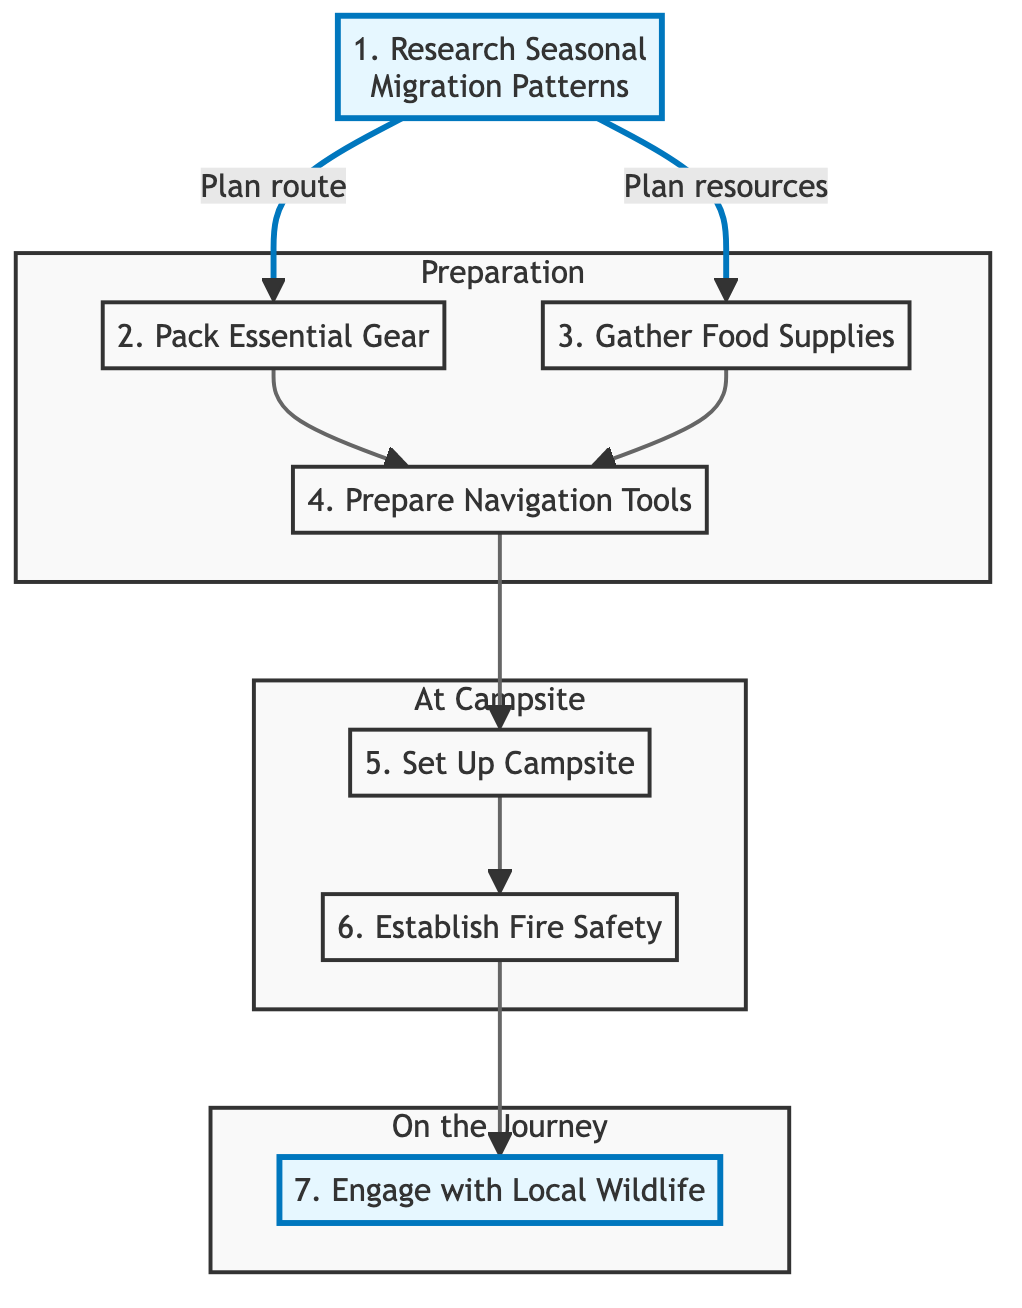What is the first step in the flow chart? The first step in the flow chart is the node labeled "Research Seasonal Migration Patterns." It is the starting point of the flow and serves as the foundation for the subsequent actions.
Answer: Research Seasonal Migration Patterns How many nodes are present in this diagram? The diagram contains a total of seven nodes, each representing a distinct step in preparing for a nomadic journey.
Answer: 7 What step follows "Pack Essential Gear"? After "Pack Essential Gear," the next step in the flow chart is "Prepare Navigation Tools." This connection indicates the order in which preparations are made.
Answer: Prepare Navigation Tools What is the last step in the diagram? The last step in the flow chart is "Engage with Local Wildlife." It is positioned after all the preparation and campsite setup steps, indicating it occurs during the journey.
Answer: Engage with Local Wildlife Which nodes are part of the "Preparation" subgraph? The "Preparation" subgraph includes the nodes "Pack Essential Gear," "Gather Food Supplies," and "Prepare Navigation Tools." These nodes are grouped together to represent the initial stages of preparing for the journey.
Answer: Pack Essential Gear, Gather Food Supplies, Prepare Navigation Tools What actions are taken after "Set Up Campsite"? The action taken after "Set Up Campsite" is "Establish Fire Safety." This sequence indicates that fire safety measures should be implemented after setting up the campsite.
Answer: Establish Fire Safety How does "Gather Food Supplies" relate to "Prepare Navigation Tools"? "Gather Food Supplies" connects to "Prepare Navigation Tools" through "Pack Essential Gear," as both food supplies and gear packing are prerequisites to navigation tools, indicating they need to be completed beforehand.
Answer: Both connect through Pack Essential Gear What do the arrows in the diagram represent? The arrows in the diagram represent the flow and sequence of actions necessary to prepare for the nomadic journey, showing the progression from one step to the next.
Answer: Sequence of actions 